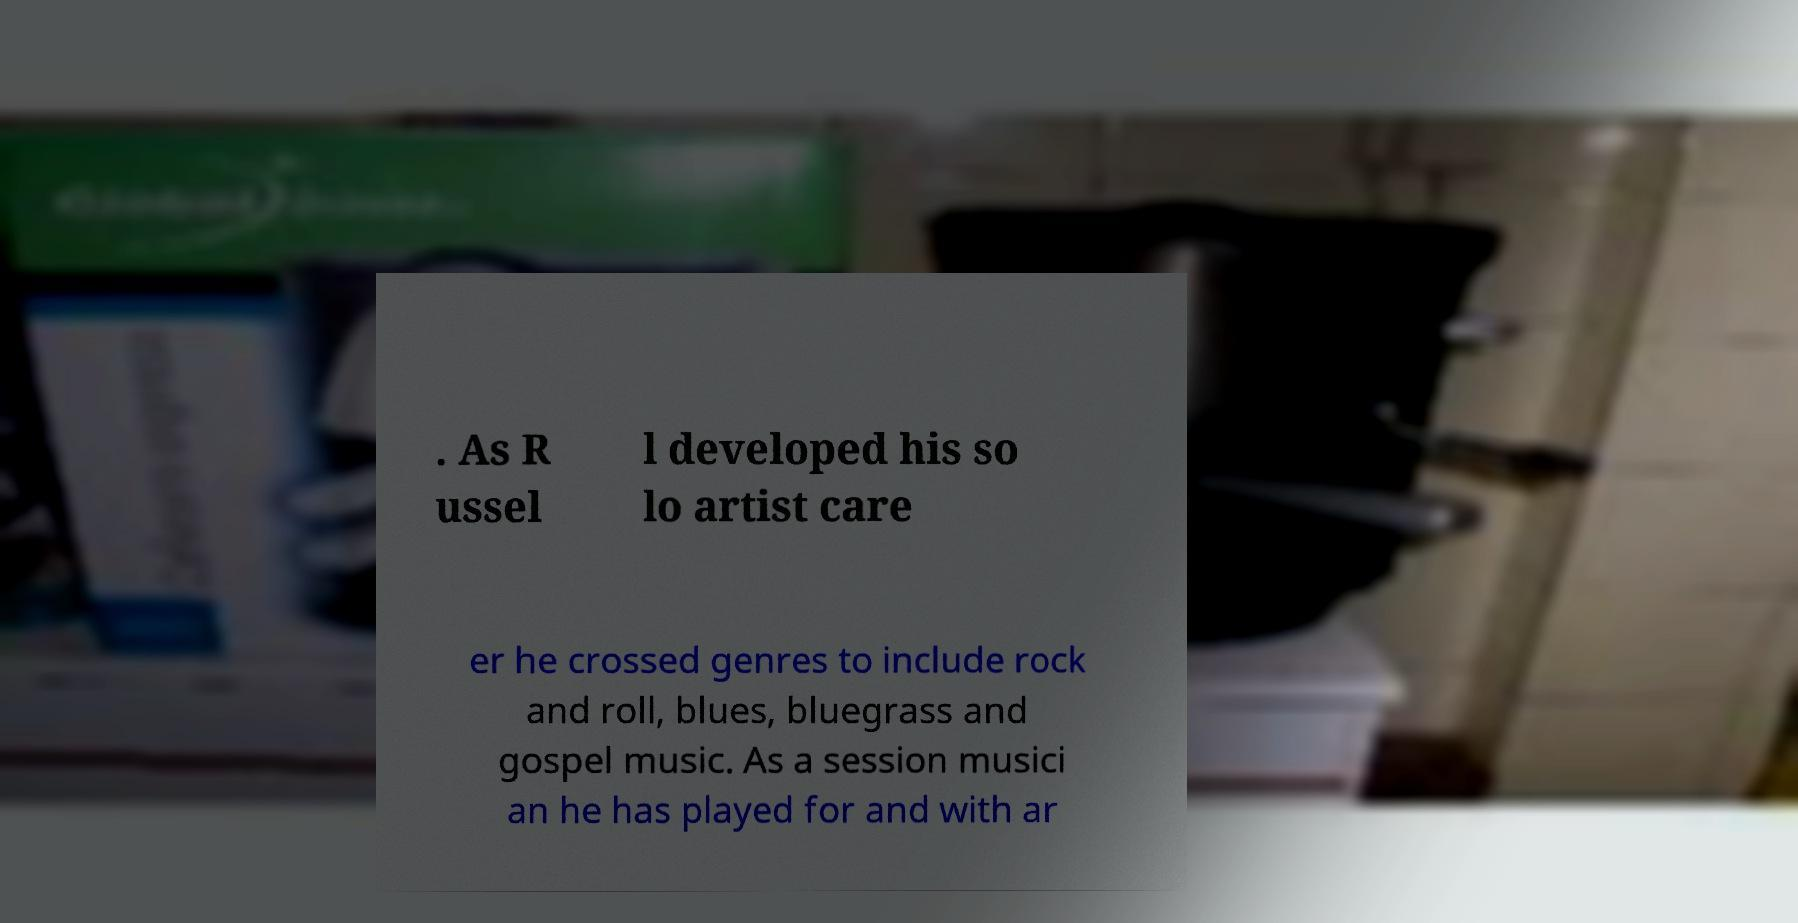There's text embedded in this image that I need extracted. Can you transcribe it verbatim? . As R ussel l developed his so lo artist care er he crossed genres to include rock and roll, blues, bluegrass and gospel music. As a session musici an he has played for and with ar 